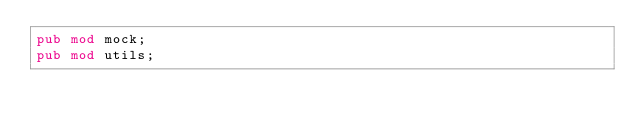<code> <loc_0><loc_0><loc_500><loc_500><_Rust_>pub mod mock;
pub mod utils;
</code> 